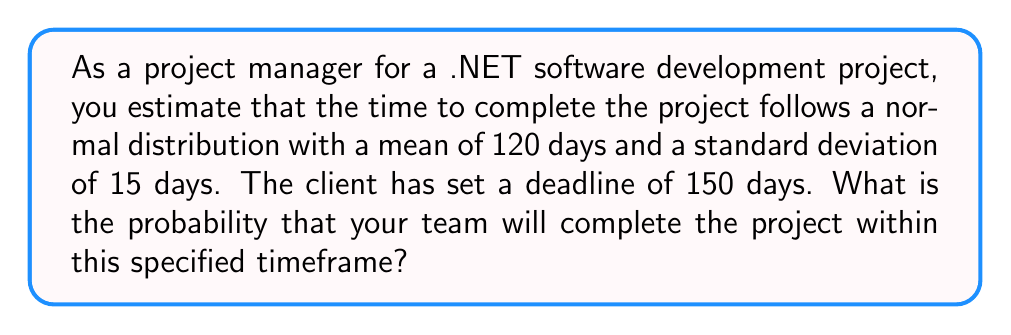Can you answer this question? To solve this problem, we need to use the properties of the normal distribution and calculate the z-score for the given deadline.

1. Given information:
   - Mean (μ) = 120 days
   - Standard deviation (σ) = 15 days
   - Deadline = 150 days

2. Calculate the z-score:
   The z-score represents how many standard deviations the deadline is from the mean.
   
   $$z = \frac{x - \mu}{\sigma}$$
   
   where x is the deadline, μ is the mean, and σ is the standard deviation.

   $$z = \frac{150 - 120}{15} = \frac{30}{15} = 2$$

3. Use the standard normal distribution table or a calculator to find the probability:
   The z-score of 2 corresponds to a cumulative probability of approximately 0.9772.

4. Interpret the result:
   This means that there is a 97.72% chance that the project will be completed within 150 days or less.

The probability of completing the project within the specified timeframe is the area under the normal distribution curve to the left of the z-score, which is 0.9772 or 97.72%.
Answer: The probability of completing the project within 150 days is approximately 0.9772 or 97.72%. 